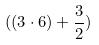Convert formula to latex. <formula><loc_0><loc_0><loc_500><loc_500>( ( 3 \cdot 6 ) + \frac { 3 } { 2 } )</formula> 